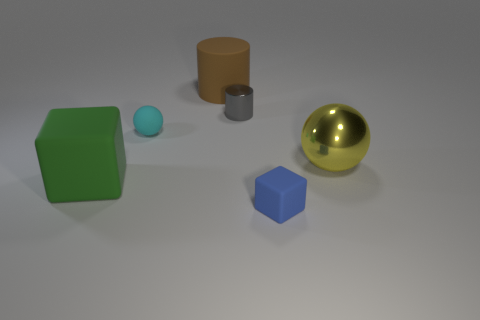What is the material of the sphere in front of the small matte thing that is behind the matte block that is to the right of the big green thing?
Your answer should be compact. Metal. The ball to the right of the brown cylinder is what color?
Your answer should be compact. Yellow. Is there any other thing that is the same shape as the yellow object?
Your answer should be compact. Yes. There is a cylinder in front of the rubber object behind the small ball; what size is it?
Offer a terse response. Small. Are there an equal number of tiny metal things right of the small blue matte block and small cylinders on the left side of the large brown matte object?
Provide a succinct answer. Yes. Are there any other things that have the same size as the rubber ball?
Give a very brief answer. Yes. There is a small cube that is made of the same material as the large cylinder; what is its color?
Your answer should be compact. Blue. Is the brown object made of the same material as the block to the left of the blue cube?
Your response must be concise. Yes. What is the color of the rubber thing that is both right of the cyan thing and behind the blue block?
Your answer should be very brief. Brown. What number of cubes are either green matte objects or small metallic objects?
Keep it short and to the point. 1. 